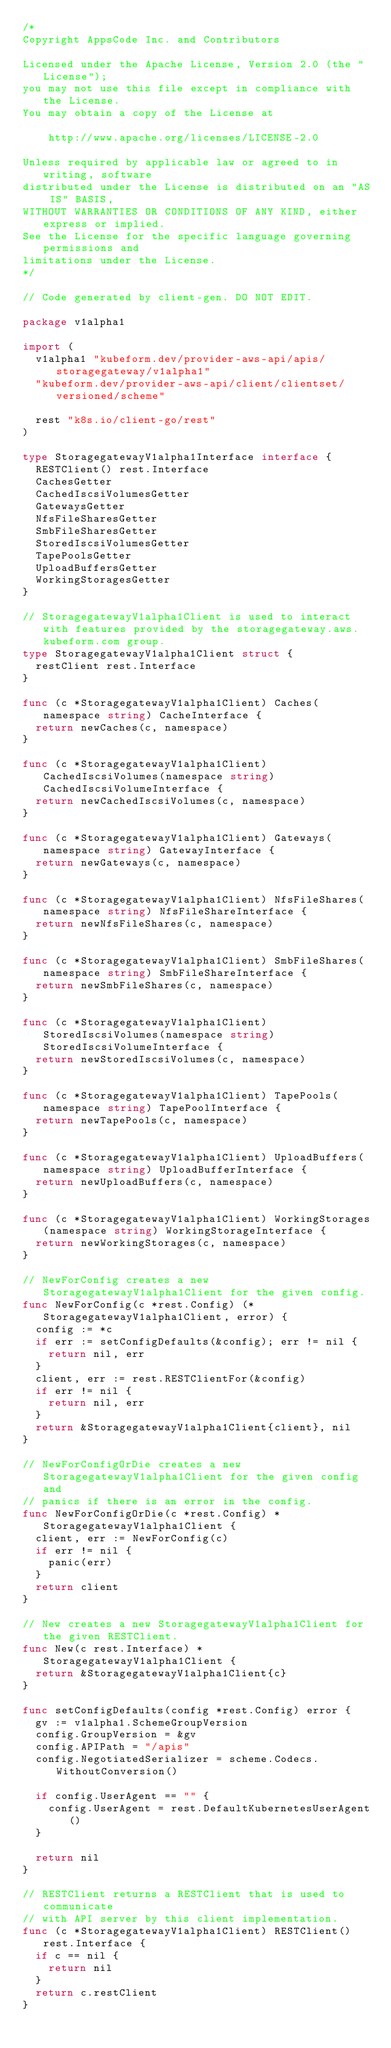<code> <loc_0><loc_0><loc_500><loc_500><_Go_>/*
Copyright AppsCode Inc. and Contributors

Licensed under the Apache License, Version 2.0 (the "License");
you may not use this file except in compliance with the License.
You may obtain a copy of the License at

    http://www.apache.org/licenses/LICENSE-2.0

Unless required by applicable law or agreed to in writing, software
distributed under the License is distributed on an "AS IS" BASIS,
WITHOUT WARRANTIES OR CONDITIONS OF ANY KIND, either express or implied.
See the License for the specific language governing permissions and
limitations under the License.
*/

// Code generated by client-gen. DO NOT EDIT.

package v1alpha1

import (
	v1alpha1 "kubeform.dev/provider-aws-api/apis/storagegateway/v1alpha1"
	"kubeform.dev/provider-aws-api/client/clientset/versioned/scheme"

	rest "k8s.io/client-go/rest"
)

type StoragegatewayV1alpha1Interface interface {
	RESTClient() rest.Interface
	CachesGetter
	CachedIscsiVolumesGetter
	GatewaysGetter
	NfsFileSharesGetter
	SmbFileSharesGetter
	StoredIscsiVolumesGetter
	TapePoolsGetter
	UploadBuffersGetter
	WorkingStoragesGetter
}

// StoragegatewayV1alpha1Client is used to interact with features provided by the storagegateway.aws.kubeform.com group.
type StoragegatewayV1alpha1Client struct {
	restClient rest.Interface
}

func (c *StoragegatewayV1alpha1Client) Caches(namespace string) CacheInterface {
	return newCaches(c, namespace)
}

func (c *StoragegatewayV1alpha1Client) CachedIscsiVolumes(namespace string) CachedIscsiVolumeInterface {
	return newCachedIscsiVolumes(c, namespace)
}

func (c *StoragegatewayV1alpha1Client) Gateways(namespace string) GatewayInterface {
	return newGateways(c, namespace)
}

func (c *StoragegatewayV1alpha1Client) NfsFileShares(namespace string) NfsFileShareInterface {
	return newNfsFileShares(c, namespace)
}

func (c *StoragegatewayV1alpha1Client) SmbFileShares(namespace string) SmbFileShareInterface {
	return newSmbFileShares(c, namespace)
}

func (c *StoragegatewayV1alpha1Client) StoredIscsiVolumes(namespace string) StoredIscsiVolumeInterface {
	return newStoredIscsiVolumes(c, namespace)
}

func (c *StoragegatewayV1alpha1Client) TapePools(namespace string) TapePoolInterface {
	return newTapePools(c, namespace)
}

func (c *StoragegatewayV1alpha1Client) UploadBuffers(namespace string) UploadBufferInterface {
	return newUploadBuffers(c, namespace)
}

func (c *StoragegatewayV1alpha1Client) WorkingStorages(namespace string) WorkingStorageInterface {
	return newWorkingStorages(c, namespace)
}

// NewForConfig creates a new StoragegatewayV1alpha1Client for the given config.
func NewForConfig(c *rest.Config) (*StoragegatewayV1alpha1Client, error) {
	config := *c
	if err := setConfigDefaults(&config); err != nil {
		return nil, err
	}
	client, err := rest.RESTClientFor(&config)
	if err != nil {
		return nil, err
	}
	return &StoragegatewayV1alpha1Client{client}, nil
}

// NewForConfigOrDie creates a new StoragegatewayV1alpha1Client for the given config and
// panics if there is an error in the config.
func NewForConfigOrDie(c *rest.Config) *StoragegatewayV1alpha1Client {
	client, err := NewForConfig(c)
	if err != nil {
		panic(err)
	}
	return client
}

// New creates a new StoragegatewayV1alpha1Client for the given RESTClient.
func New(c rest.Interface) *StoragegatewayV1alpha1Client {
	return &StoragegatewayV1alpha1Client{c}
}

func setConfigDefaults(config *rest.Config) error {
	gv := v1alpha1.SchemeGroupVersion
	config.GroupVersion = &gv
	config.APIPath = "/apis"
	config.NegotiatedSerializer = scheme.Codecs.WithoutConversion()

	if config.UserAgent == "" {
		config.UserAgent = rest.DefaultKubernetesUserAgent()
	}

	return nil
}

// RESTClient returns a RESTClient that is used to communicate
// with API server by this client implementation.
func (c *StoragegatewayV1alpha1Client) RESTClient() rest.Interface {
	if c == nil {
		return nil
	}
	return c.restClient
}
</code> 